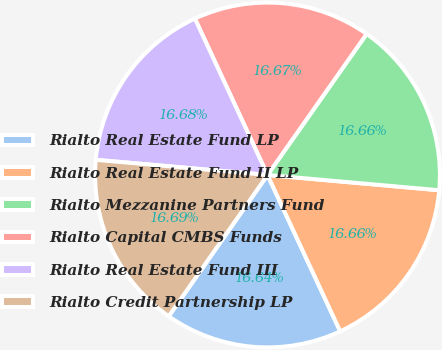Convert chart to OTSL. <chart><loc_0><loc_0><loc_500><loc_500><pie_chart><fcel>Rialto Real Estate Fund LP<fcel>Rialto Real Estate Fund II LP<fcel>Rialto Mezzanine Partners Fund<fcel>Rialto Capital CMBS Funds<fcel>Rialto Real Estate Fund III<fcel>Rialto Credit Partnership LP<nl><fcel>16.64%<fcel>16.66%<fcel>16.66%<fcel>16.67%<fcel>16.68%<fcel>16.69%<nl></chart> 